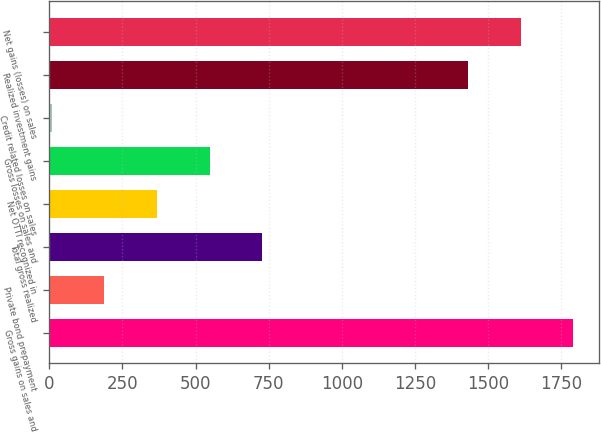Convert chart. <chart><loc_0><loc_0><loc_500><loc_500><bar_chart><fcel>Gross gains on sales and<fcel>Private bond prepayment<fcel>Total gross realized<fcel>Net OTTI recognized in<fcel>Gross losses on sales and<fcel>Credit related losses on sales<fcel>Realized investment gains<fcel>Net gains (losses) on sales<nl><fcel>1791.2<fcel>188.1<fcel>728.4<fcel>368.2<fcel>548.3<fcel>8<fcel>1431<fcel>1611.1<nl></chart> 